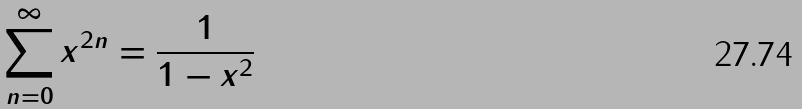Convert formula to latex. <formula><loc_0><loc_0><loc_500><loc_500>\sum _ { n = 0 } ^ { \infty } x ^ { 2 n } = \frac { 1 } { 1 - x ^ { 2 } }</formula> 